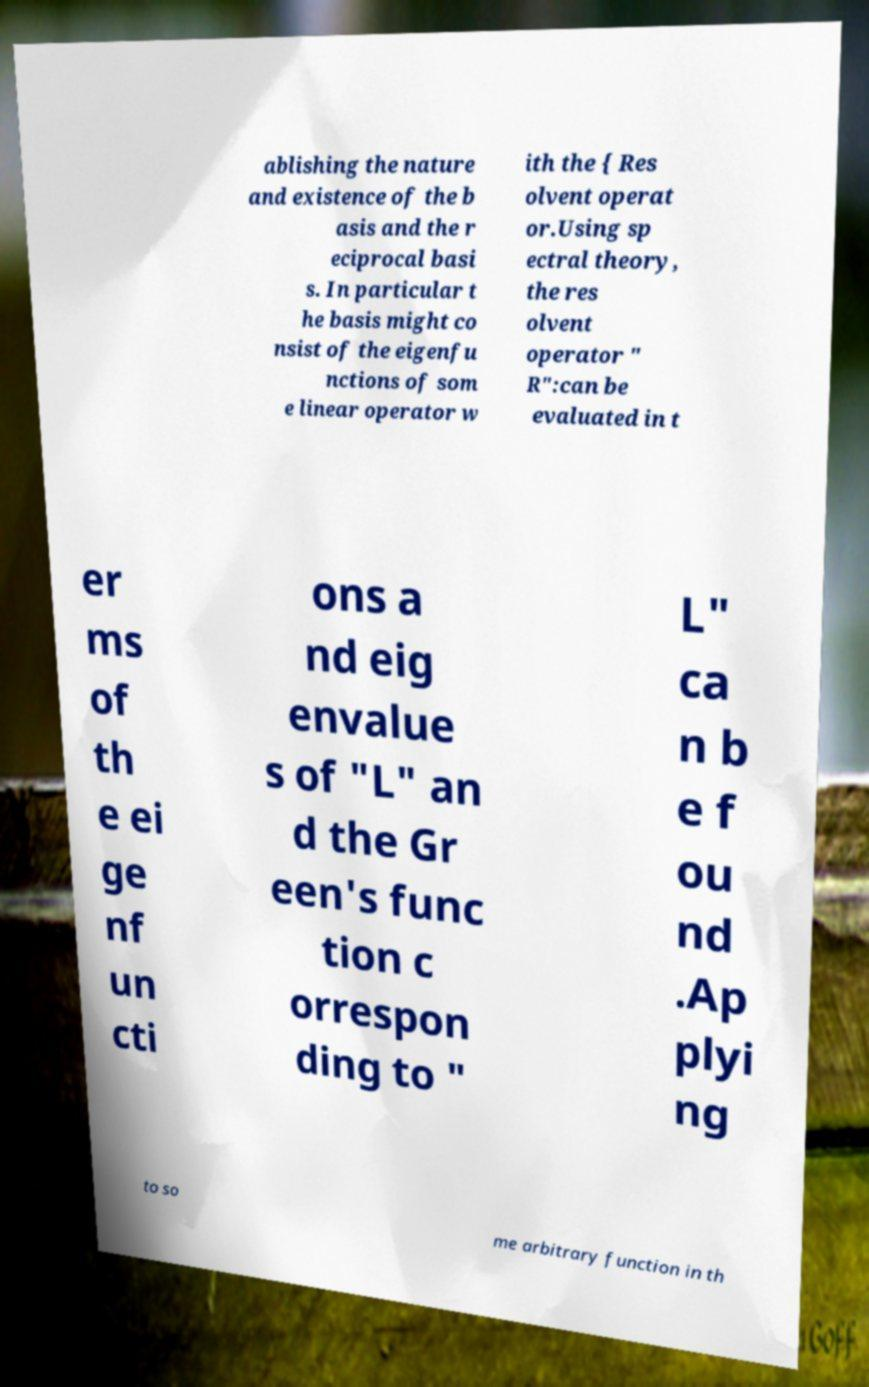There's text embedded in this image that I need extracted. Can you transcribe it verbatim? ablishing the nature and existence of the b asis and the r eciprocal basi s. In particular t he basis might co nsist of the eigenfu nctions of som e linear operator w ith the { Res olvent operat or.Using sp ectral theory, the res olvent operator " R":can be evaluated in t er ms of th e ei ge nf un cti ons a nd eig envalue s of "L" an d the Gr een's func tion c orrespon ding to " L" ca n b e f ou nd .Ap plyi ng to so me arbitrary function in th 